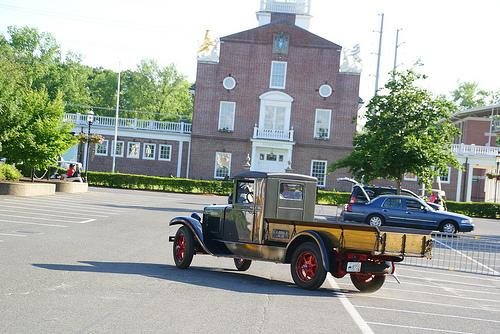How would you describe the atmosphere and sentiment of the image? The atmosphere appears to be relaxed and cheerful with people enjoying the outdoors, and various vehicles parked or driving through the parking lot in a pleasant environment. Examine the relationships between the objects in this image. The red brick building has white railing, trees in the background, and it overlooks a parking lot with an antique truck, a blue car, metal railing, and white lines. Two golf carts are driving through the lot, and people are enjoying the outdoors nearby. Count the total number of vehicles shown in the image. A total of four vehicles are visible in the image: an antique truck, a blue car, and two golf carts. What are the most notable features of the antique truck in the parking lot? The antique truck has a rear tire and a red rim, casting a shadow on the ground behind it. What is happening in the parking lot of the red brick building? In the parking lot, there is an antique truck parked, a blue car parked, two golf carts are driving through, and metal railing and white lines can be seen on the surface. What is the main subject of the image regarding human activities? People are enjoying the outdoors near the red brick building with the antique truck and other vehicles in the parking lot. Identify the main elements in the image and their locations. There is a red brick building on the left side with white railing, trees behind it, an antique truck and a blue car in the parking lot, white lines and metal railing on the lot's surface, two golf carts driving, and people enjoying the outdoors. Describe any peculiar or unique details about an object in the image. A white man eating an orange is positioned near the vehicles in the parking lot, only occupying a small portion of the image. What are the different types of vehicles present in the image? An antique truck, a blue car, and two golf carts are present in the image. What type of image understanding task requires deeper reasoning to analyze this image? Complex reasoning task is required to analyze the objects' interactions and relationships within the parking lot scene, alongside the sentiment of the image. Can you notice a bird sitting on the metal railing in the parking lot? There is no mention of any bird or animal that is part of the scene in the given information about the image. Can you see a group of people sitting on a bench under the trees in the parking lot? There is no mention of people sitting on a bench in the given information about the image. Are there purple flowers and bushes growing near the red brick building in the background? There is no mention of any flowers, particularly purple ones, or bushes in the given information about the image. Is the car parked in the lot green in color and have visible damages on its side? There is no mention of a green car or any car with visible damages in the given information about the image. Is there a person wearing a blue jacket walking their dog in the parking lot? There is no mention of any person walking a dog in the given information about the image. Is there a yellow bicycle leaning against the white railing on the brick building? There is no mention of a bicycle, particularly a yellow one, in the given information about the image. 